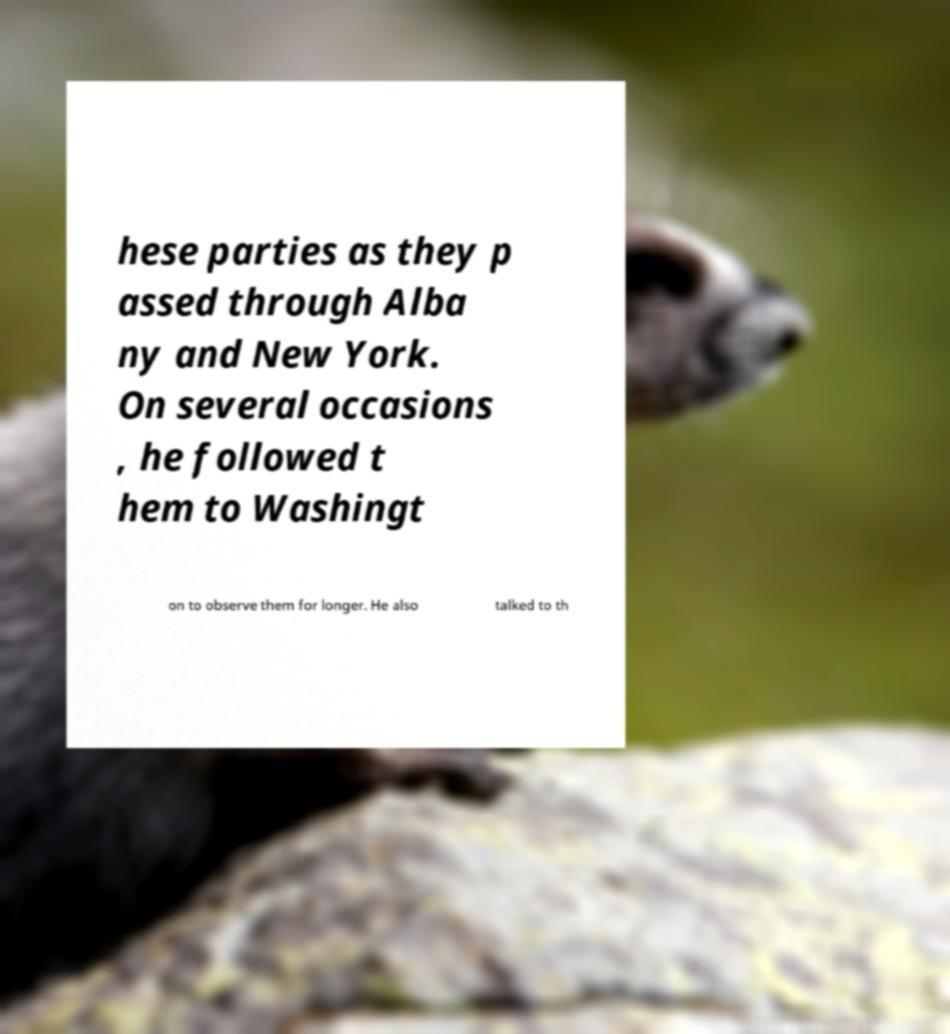I need the written content from this picture converted into text. Can you do that? hese parties as they p assed through Alba ny and New York. On several occasions , he followed t hem to Washingt on to observe them for longer. He also talked to th 